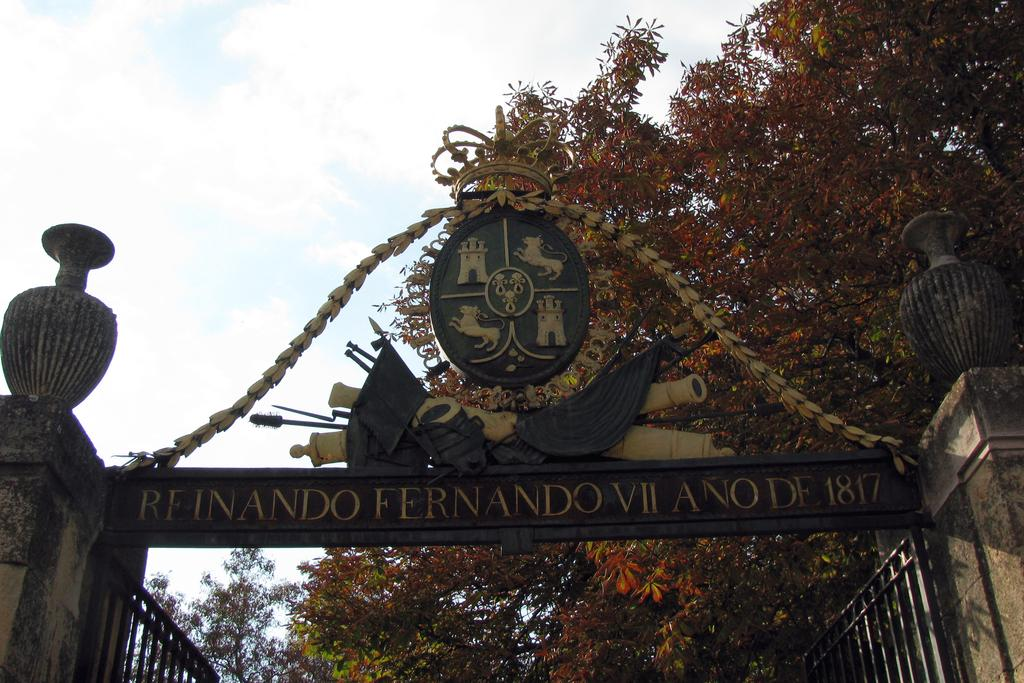<image>
Render a clear and concise summary of the photo. A steel gate that bears the words reinando fernando VII ano de 1817. 